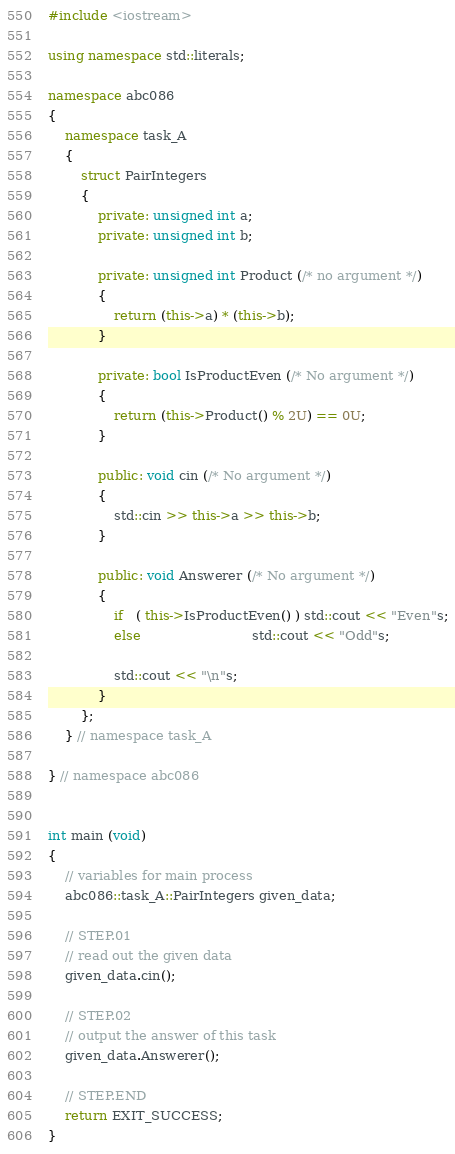<code> <loc_0><loc_0><loc_500><loc_500><_C++_>#include <iostream>

using namespace std::literals;

namespace abc086
{
	namespace task_A
	{
		struct PairIntegers
		{
			private: unsigned int a;
			private: unsigned int b;

			private: unsigned int Product (/* no argument */)
			{
				return (this->a) * (this->b);
			}

			private: bool IsProductEven (/* No argument */)
			{
				return (this->Product() % 2U) == 0U;
			}

			public: void cin (/* No argument */)
			{
				std::cin >> this->a >> this->b;
			}

			public: void Answerer (/* No argument */)
			{
				if   ( this->IsProductEven() ) std::cout << "Even"s;
				else                           std::cout << "Odd"s;

				std::cout << "\n"s;
			}
		};
	} // namespace task_A
	
} // namespace abc086


int main (void)
{
	// variables for main process
	abc086::task_A::PairIntegers given_data;

	// STEP.01
	// read out the given data
	given_data.cin();

	// STEP.02
	// output the answer of this task
	given_data.Answerer();

	// STEP.END
	return EXIT_SUCCESS;
}</code> 